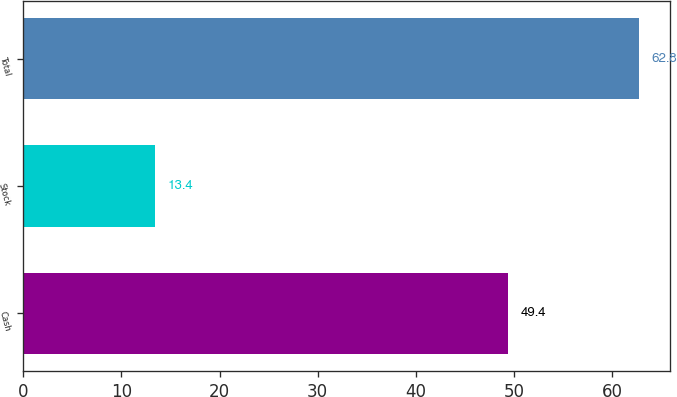Convert chart. <chart><loc_0><loc_0><loc_500><loc_500><bar_chart><fcel>Cash<fcel>Stock<fcel>Total<nl><fcel>49.4<fcel>13.4<fcel>62.8<nl></chart> 